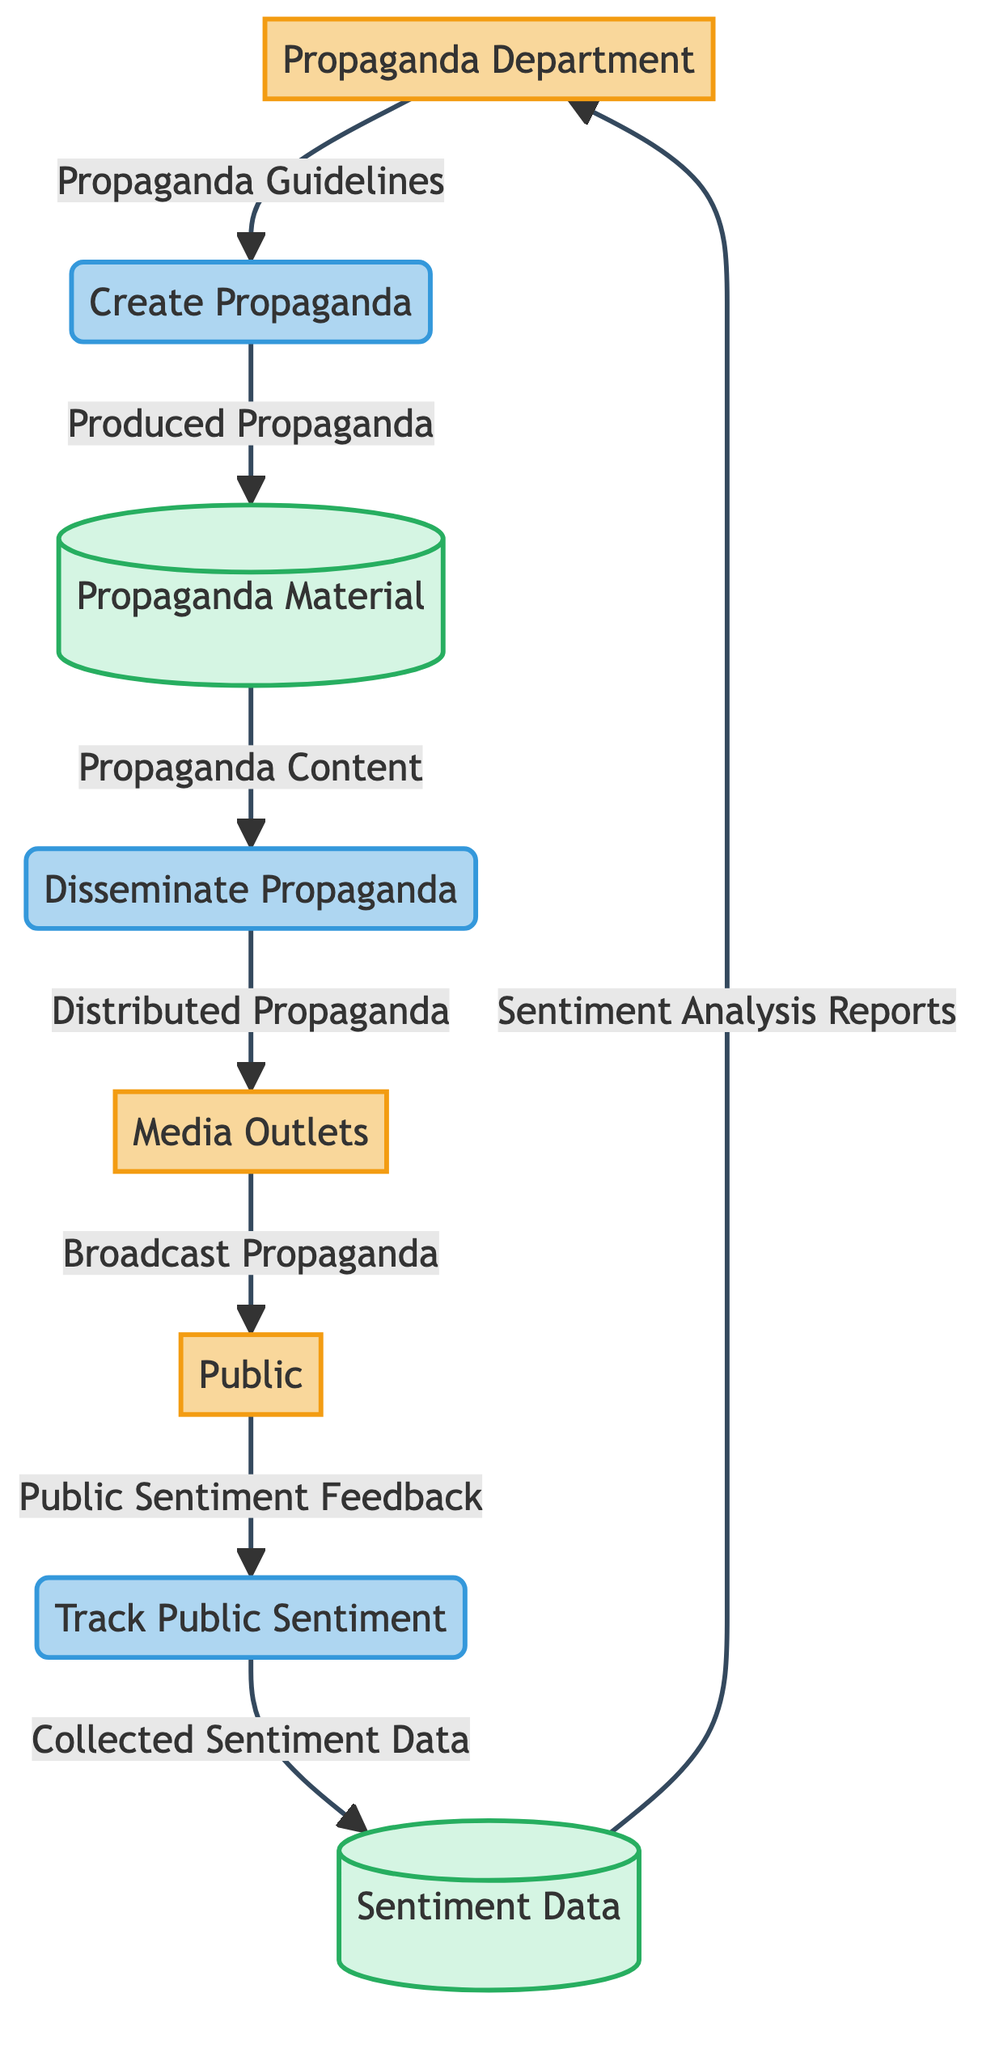What is the output of the "Create Propaganda" process? The output of the "Create Propaganda" process is "Produced Propaganda," which indicates the completed propaganda material ready for distribution.
Answer: Produced Propaganda How many entities are in the diagram? The diagram includes three external entities: Propaganda Department, Media Outlets, and Public, totaling three entities.
Answer: 3 What does the "Public Sentiment Feedback" data flow represent? The "Public Sentiment Feedback" data flow represents feedback data collected from the public reflecting their sentiments and opinions regarding the propaganda.
Answer: Feedback data Which process is responsible for distributing propaganda material? The process responsible for distributing propaganda material is the "Disseminate Propaganda" process, which handles the distribution through media outlets.
Answer: Disseminate Propaganda What is the final output delivered back to the Propaganda Department? The final output delivered back to the Propaganda Department is "Sentiment Analysis Reports," which are used to adjust and improve propaganda strategies.
Answer: Sentiment Analysis Reports In what flow is "Broadcast Propaganda" involved? "Broadcast Propaganda" is involved in the flow from Media Outlets to the Public, where propaganda material is published or broadcasted to reach the civilian population.
Answer: Media Outlets to Public Explain how the sentiment data is assessed in the system. Sentiment data is assessed through the "Track Public Sentiment" process, which collects feedback from the Public, analyzes it, and stores the results as "Collected Sentiment Data" in the Sentiment Data store. This data is then used to generate the "Sentiment Analysis Reports" back to the Propaganda Department.
Answer: Processed analysis What type of entity is "Propaganda Material"? "Propaganda Material" is categorized as a data store, which serves as the repository for all types of propaganda content, including posters, films, and articles.
Answer: Data Store Which entity receives the "Distributed Propaganda"? The entity that receives the "Distributed Propaganda" is the Media Outlets, as they are the ones responsible for disseminating the propaganda material to the public.
Answer: Media Outlets 